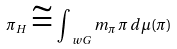Convert formula to latex. <formula><loc_0><loc_0><loc_500><loc_500>\pi _ { H } \cong \int _ { \ w G } m _ { \pi } \, \pi \, d \mu ( \pi )</formula> 